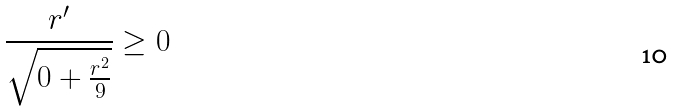Convert formula to latex. <formula><loc_0><loc_0><loc_500><loc_500>\frac { r ^ { \prime } } { \sqrt { 0 + \frac { r ^ { 2 } } { 9 } } } \geq 0</formula> 